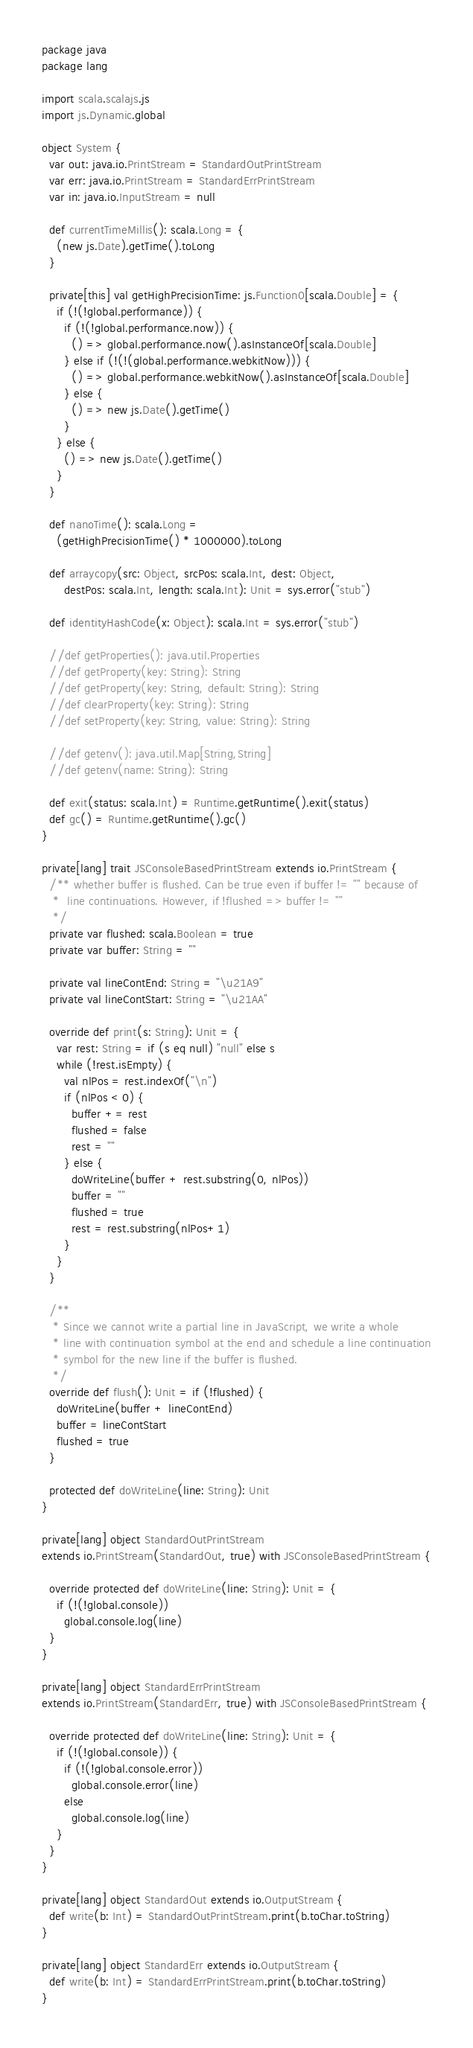<code> <loc_0><loc_0><loc_500><loc_500><_Scala_>package java
package lang

import scala.scalajs.js
import js.Dynamic.global

object System {
  var out: java.io.PrintStream = StandardOutPrintStream
  var err: java.io.PrintStream = StandardErrPrintStream
  var in: java.io.InputStream = null

  def currentTimeMillis(): scala.Long = {
    (new js.Date).getTime().toLong
  }

  private[this] val getHighPrecisionTime: js.Function0[scala.Double] = {
    if (!(!global.performance)) {
      if (!(!global.performance.now)) {
        () => global.performance.now().asInstanceOf[scala.Double]
      } else if (!(!(global.performance.webkitNow))) {
        () => global.performance.webkitNow().asInstanceOf[scala.Double]
      } else {
        () => new js.Date().getTime()
      }
    } else {
      () => new js.Date().getTime()
    }
  }

  def nanoTime(): scala.Long =
    (getHighPrecisionTime() * 1000000).toLong

  def arraycopy(src: Object, srcPos: scala.Int, dest: Object,
      destPos: scala.Int, length: scala.Int): Unit = sys.error("stub")

  def identityHashCode(x: Object): scala.Int = sys.error("stub")

  //def getProperties(): java.util.Properties
  //def getProperty(key: String): String
  //def getProperty(key: String, default: String): String
  //def clearProperty(key: String): String
  //def setProperty(key: String, value: String): String

  //def getenv(): java.util.Map[String,String]
  //def getenv(name: String): String

  def exit(status: scala.Int) = Runtime.getRuntime().exit(status)
  def gc() = Runtime.getRuntime().gc()
}

private[lang] trait JSConsoleBasedPrintStream extends io.PrintStream {
  /** whether buffer is flushed. Can be true even if buffer != "" because of
   *  line continuations. However, if !flushed => buffer != ""
   */
  private var flushed: scala.Boolean = true
  private var buffer: String = ""

  private val lineContEnd: String = "\u21A9"
  private val lineContStart: String = "\u21AA"

  override def print(s: String): Unit = {
    var rest: String = if (s eq null) "null" else s
    while (!rest.isEmpty) {
      val nlPos = rest.indexOf("\n")
      if (nlPos < 0) {
        buffer += rest
        flushed = false
        rest = ""
      } else {
        doWriteLine(buffer + rest.substring(0, nlPos))
        buffer = ""
        flushed = true
        rest = rest.substring(nlPos+1)
      }
    }
  }

  /**
   * Since we cannot write a partial line in JavaScript, we write a whole
   * line with continuation symbol at the end and schedule a line continuation
   * symbol for the new line if the buffer is flushed.
   */
  override def flush(): Unit = if (!flushed) {
    doWriteLine(buffer + lineContEnd)
    buffer = lineContStart
    flushed = true
  }

  protected def doWriteLine(line: String): Unit
}

private[lang] object StandardOutPrintStream
extends io.PrintStream(StandardOut, true) with JSConsoleBasedPrintStream {

  override protected def doWriteLine(line: String): Unit = {
    if (!(!global.console))
      global.console.log(line)
  }
}

private[lang] object StandardErrPrintStream
extends io.PrintStream(StandardErr, true) with JSConsoleBasedPrintStream {

  override protected def doWriteLine(line: String): Unit = {
    if (!(!global.console)) {
      if (!(!global.console.error))
        global.console.error(line)
      else
        global.console.log(line)
    }
  }
}

private[lang] object StandardOut extends io.OutputStream {
  def write(b: Int) = StandardOutPrintStream.print(b.toChar.toString)
}

private[lang] object StandardErr extends io.OutputStream {
  def write(b: Int) = StandardErrPrintStream.print(b.toChar.toString)
}
</code> 